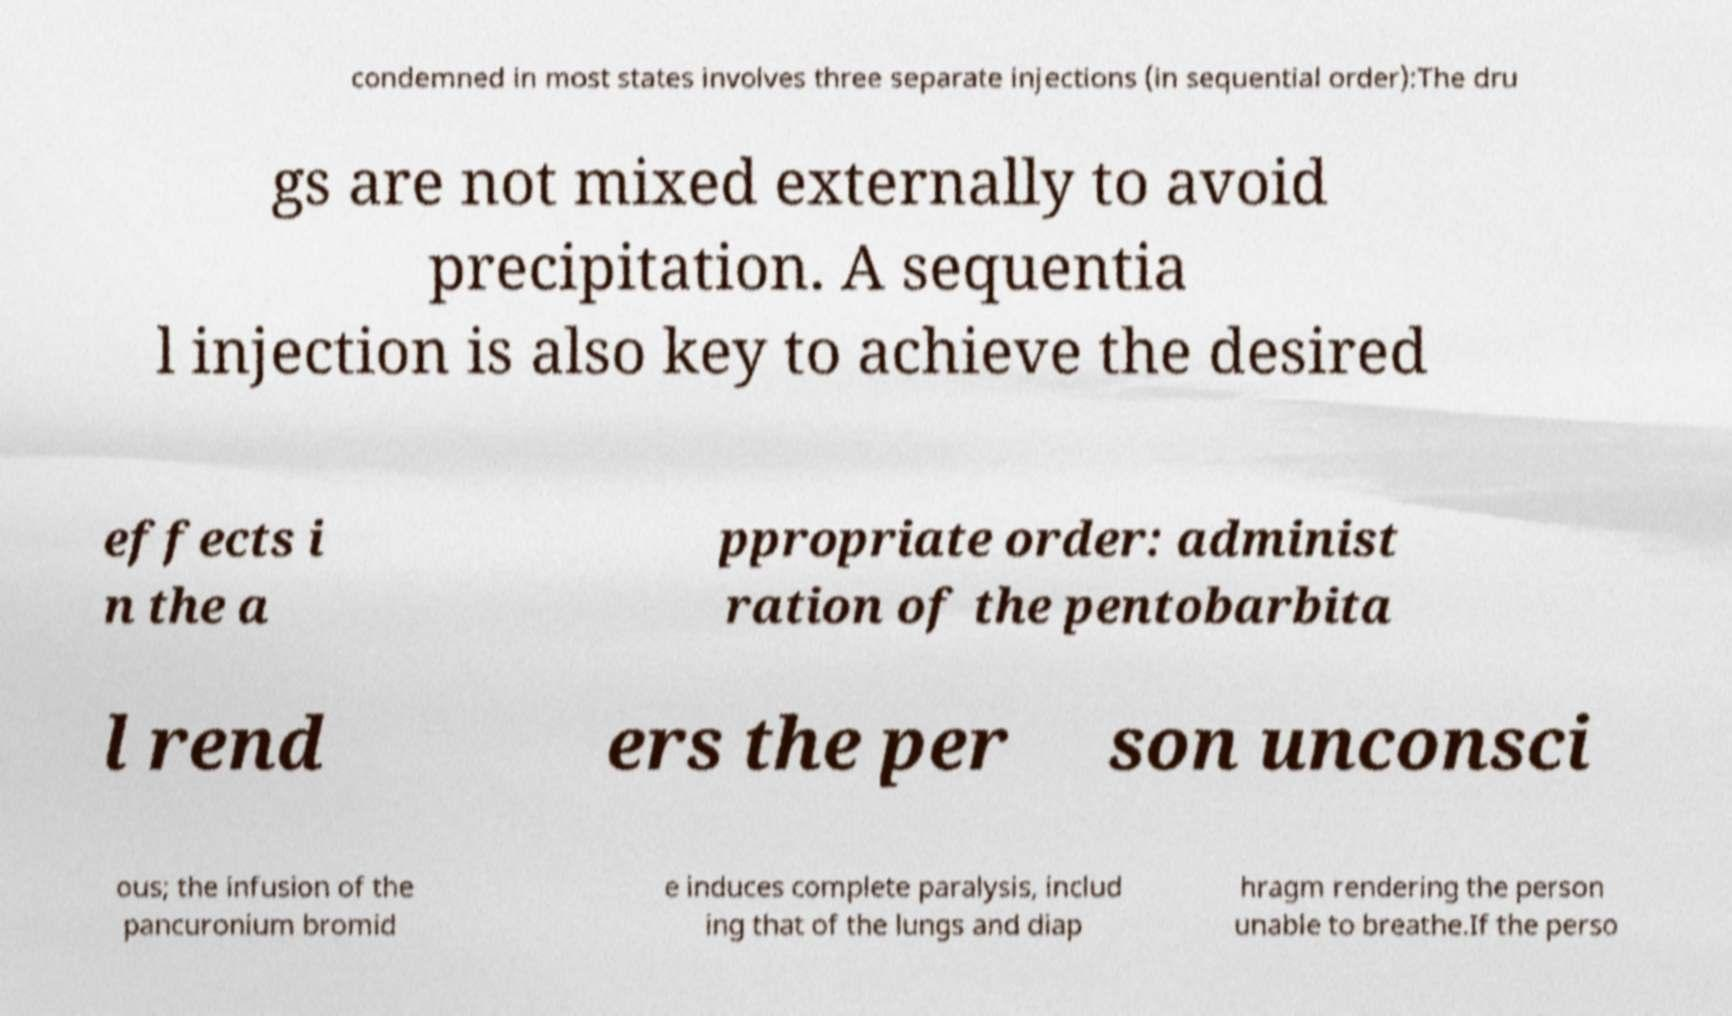Can you read and provide the text displayed in the image?This photo seems to have some interesting text. Can you extract and type it out for me? condemned in most states involves three separate injections (in sequential order):The dru gs are not mixed externally to avoid precipitation. A sequentia l injection is also key to achieve the desired effects i n the a ppropriate order: administ ration of the pentobarbita l rend ers the per son unconsci ous; the infusion of the pancuronium bromid e induces complete paralysis, includ ing that of the lungs and diap hragm rendering the person unable to breathe.If the perso 